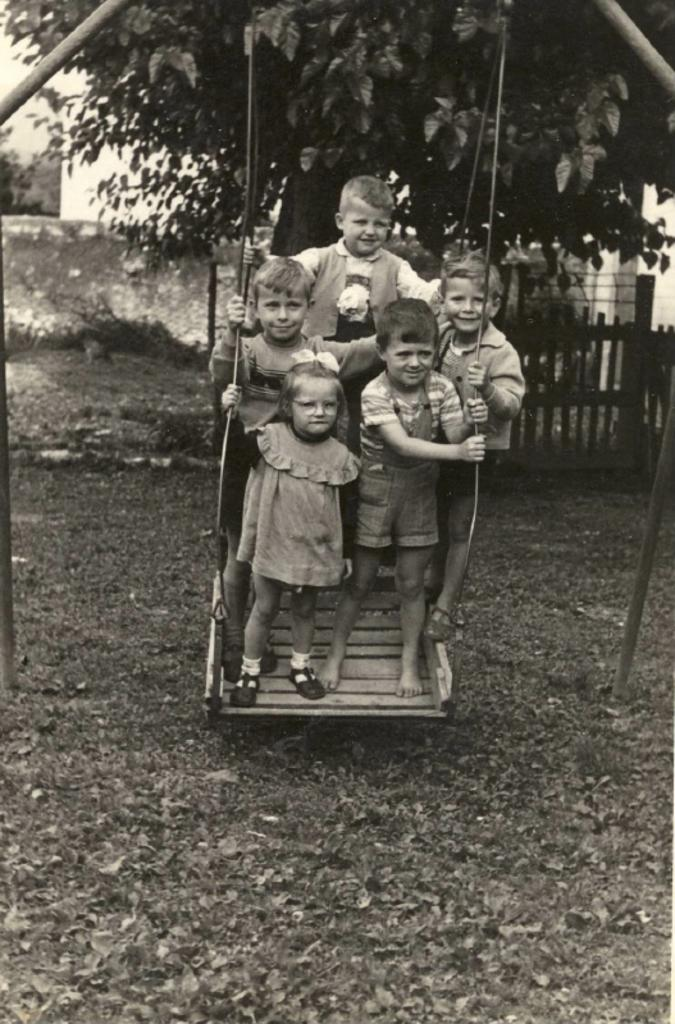How many people are in the image? There is a group of persons in the image. What are the people in the image doing? The persons are standing and smiling. What can be seen in the background of the image? There is a tree, a fence, and plants in the background of the image. What is present on the ground in the image? Dry leaves are present on the ground in the image. What type of process can be seen happening in the image? There is no process visible in the image; it features a group of standing and smiling persons with a background of trees, fence, and plants. Are the persons in the image playing any games or engaging in any activities? The provided facts do not mention any games or activities; the persons are simply standing and smiling. 